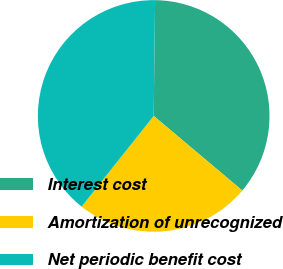<chart> <loc_0><loc_0><loc_500><loc_500><pie_chart><fcel>Interest cost<fcel>Amortization of unrecognized<fcel>Net periodic benefit cost<nl><fcel>35.94%<fcel>24.56%<fcel>39.5%<nl></chart> 